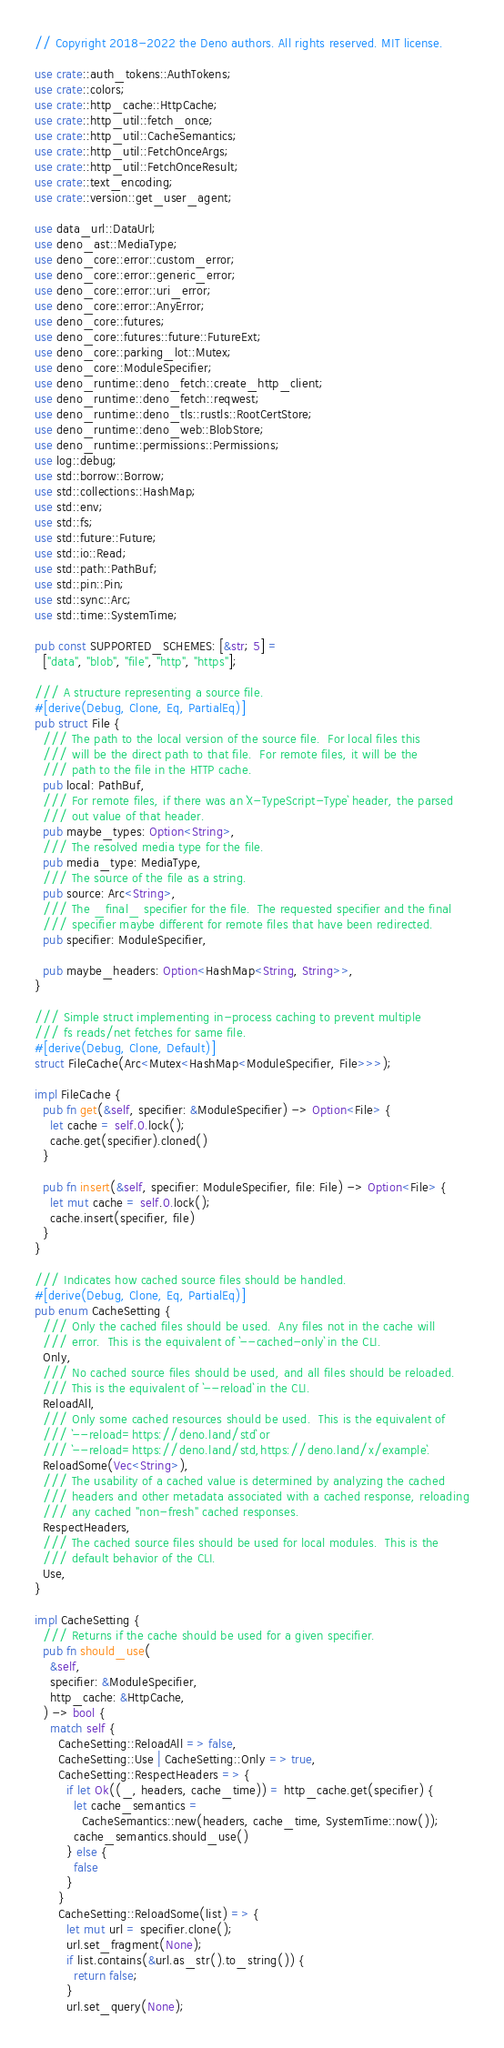<code> <loc_0><loc_0><loc_500><loc_500><_Rust_>// Copyright 2018-2022 the Deno authors. All rights reserved. MIT license.

use crate::auth_tokens::AuthTokens;
use crate::colors;
use crate::http_cache::HttpCache;
use crate::http_util::fetch_once;
use crate::http_util::CacheSemantics;
use crate::http_util::FetchOnceArgs;
use crate::http_util::FetchOnceResult;
use crate::text_encoding;
use crate::version::get_user_agent;

use data_url::DataUrl;
use deno_ast::MediaType;
use deno_core::error::custom_error;
use deno_core::error::generic_error;
use deno_core::error::uri_error;
use deno_core::error::AnyError;
use deno_core::futures;
use deno_core::futures::future::FutureExt;
use deno_core::parking_lot::Mutex;
use deno_core::ModuleSpecifier;
use deno_runtime::deno_fetch::create_http_client;
use deno_runtime::deno_fetch::reqwest;
use deno_runtime::deno_tls::rustls::RootCertStore;
use deno_runtime::deno_web::BlobStore;
use deno_runtime::permissions::Permissions;
use log::debug;
use std::borrow::Borrow;
use std::collections::HashMap;
use std::env;
use std::fs;
use std::future::Future;
use std::io::Read;
use std::path::PathBuf;
use std::pin::Pin;
use std::sync::Arc;
use std::time::SystemTime;

pub const SUPPORTED_SCHEMES: [&str; 5] =
  ["data", "blob", "file", "http", "https"];

/// A structure representing a source file.
#[derive(Debug, Clone, Eq, PartialEq)]
pub struct File {
  /// The path to the local version of the source file.  For local files this
  /// will be the direct path to that file.  For remote files, it will be the
  /// path to the file in the HTTP cache.
  pub local: PathBuf,
  /// For remote files, if there was an `X-TypeScript-Type` header, the parsed
  /// out value of that header.
  pub maybe_types: Option<String>,
  /// The resolved media type for the file.
  pub media_type: MediaType,
  /// The source of the file as a string.
  pub source: Arc<String>,
  /// The _final_ specifier for the file.  The requested specifier and the final
  /// specifier maybe different for remote files that have been redirected.
  pub specifier: ModuleSpecifier,

  pub maybe_headers: Option<HashMap<String, String>>,
}

/// Simple struct implementing in-process caching to prevent multiple
/// fs reads/net fetches for same file.
#[derive(Debug, Clone, Default)]
struct FileCache(Arc<Mutex<HashMap<ModuleSpecifier, File>>>);

impl FileCache {
  pub fn get(&self, specifier: &ModuleSpecifier) -> Option<File> {
    let cache = self.0.lock();
    cache.get(specifier).cloned()
  }

  pub fn insert(&self, specifier: ModuleSpecifier, file: File) -> Option<File> {
    let mut cache = self.0.lock();
    cache.insert(specifier, file)
  }
}

/// Indicates how cached source files should be handled.
#[derive(Debug, Clone, Eq, PartialEq)]
pub enum CacheSetting {
  /// Only the cached files should be used.  Any files not in the cache will
  /// error.  This is the equivalent of `--cached-only` in the CLI.
  Only,
  /// No cached source files should be used, and all files should be reloaded.
  /// This is the equivalent of `--reload` in the CLI.
  ReloadAll,
  /// Only some cached resources should be used.  This is the equivalent of
  /// `--reload=https://deno.land/std` or
  /// `--reload=https://deno.land/std,https://deno.land/x/example`.
  ReloadSome(Vec<String>),
  /// The usability of a cached value is determined by analyzing the cached
  /// headers and other metadata associated with a cached response, reloading
  /// any cached "non-fresh" cached responses.
  RespectHeaders,
  /// The cached source files should be used for local modules.  This is the
  /// default behavior of the CLI.
  Use,
}

impl CacheSetting {
  /// Returns if the cache should be used for a given specifier.
  pub fn should_use(
    &self,
    specifier: &ModuleSpecifier,
    http_cache: &HttpCache,
  ) -> bool {
    match self {
      CacheSetting::ReloadAll => false,
      CacheSetting::Use | CacheSetting::Only => true,
      CacheSetting::RespectHeaders => {
        if let Ok((_, headers, cache_time)) = http_cache.get(specifier) {
          let cache_semantics =
            CacheSemantics::new(headers, cache_time, SystemTime::now());
          cache_semantics.should_use()
        } else {
          false
        }
      }
      CacheSetting::ReloadSome(list) => {
        let mut url = specifier.clone();
        url.set_fragment(None);
        if list.contains(&url.as_str().to_string()) {
          return false;
        }
        url.set_query(None);</code> 